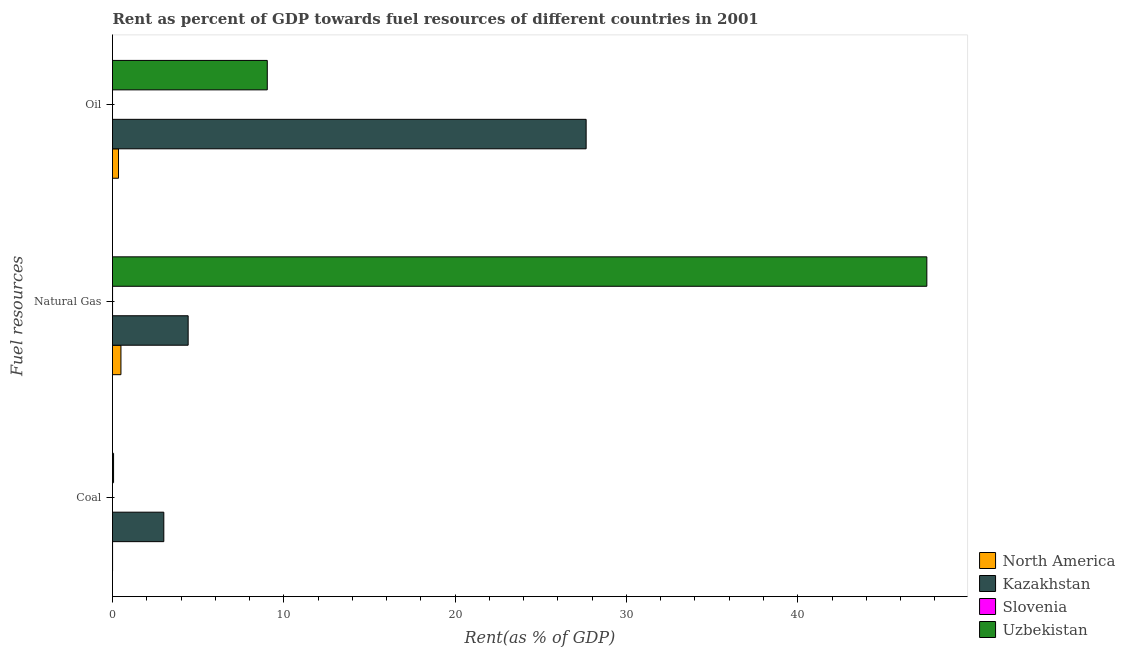Are the number of bars per tick equal to the number of legend labels?
Your answer should be compact. Yes. What is the label of the 3rd group of bars from the top?
Make the answer very short. Coal. What is the rent towards coal in Uzbekistan?
Your response must be concise. 0.06. Across all countries, what is the maximum rent towards oil?
Your response must be concise. 27.65. Across all countries, what is the minimum rent towards natural gas?
Provide a succinct answer. 0. In which country was the rent towards oil maximum?
Your response must be concise. Kazakhstan. In which country was the rent towards oil minimum?
Provide a succinct answer. Slovenia. What is the total rent towards coal in the graph?
Your answer should be compact. 3.06. What is the difference between the rent towards oil in Uzbekistan and that in Kazakhstan?
Offer a very short reply. -18.61. What is the difference between the rent towards coal in North America and the rent towards oil in Slovenia?
Your response must be concise. 0. What is the average rent towards natural gas per country?
Provide a succinct answer. 13.11. What is the difference between the rent towards natural gas and rent towards oil in Slovenia?
Provide a succinct answer. 0. In how many countries, is the rent towards natural gas greater than 44 %?
Keep it short and to the point. 1. What is the ratio of the rent towards coal in Uzbekistan to that in Slovenia?
Your answer should be compact. 720.28. What is the difference between the highest and the second highest rent towards oil?
Give a very brief answer. 18.61. What is the difference between the highest and the lowest rent towards coal?
Make the answer very short. 3. Is the sum of the rent towards coal in Slovenia and North America greater than the maximum rent towards natural gas across all countries?
Ensure brevity in your answer.  No. What does the 1st bar from the top in Natural Gas represents?
Give a very brief answer. Uzbekistan. What does the 4th bar from the bottom in Oil represents?
Ensure brevity in your answer.  Uzbekistan. How many bars are there?
Keep it short and to the point. 12. Are all the bars in the graph horizontal?
Offer a very short reply. Yes. How many countries are there in the graph?
Offer a terse response. 4. What is the difference between two consecutive major ticks on the X-axis?
Your answer should be compact. 10. Are the values on the major ticks of X-axis written in scientific E-notation?
Keep it short and to the point. No. Does the graph contain grids?
Provide a succinct answer. No. Where does the legend appear in the graph?
Your response must be concise. Bottom right. How many legend labels are there?
Ensure brevity in your answer.  4. How are the legend labels stacked?
Offer a terse response. Vertical. What is the title of the graph?
Provide a short and direct response. Rent as percent of GDP towards fuel resources of different countries in 2001. Does "Euro area" appear as one of the legend labels in the graph?
Provide a short and direct response. No. What is the label or title of the X-axis?
Keep it short and to the point. Rent(as % of GDP). What is the label or title of the Y-axis?
Your answer should be very brief. Fuel resources. What is the Rent(as % of GDP) in North America in Coal?
Offer a terse response. 0. What is the Rent(as % of GDP) of Kazakhstan in Coal?
Keep it short and to the point. 3. What is the Rent(as % of GDP) in Slovenia in Coal?
Offer a very short reply. 8.55127305686454e-5. What is the Rent(as % of GDP) of Uzbekistan in Coal?
Give a very brief answer. 0.06. What is the Rent(as % of GDP) in North America in Natural Gas?
Give a very brief answer. 0.49. What is the Rent(as % of GDP) of Kazakhstan in Natural Gas?
Give a very brief answer. 4.42. What is the Rent(as % of GDP) of Slovenia in Natural Gas?
Give a very brief answer. 0. What is the Rent(as % of GDP) in Uzbekistan in Natural Gas?
Ensure brevity in your answer.  47.53. What is the Rent(as % of GDP) in North America in Oil?
Provide a short and direct response. 0.35. What is the Rent(as % of GDP) in Kazakhstan in Oil?
Keep it short and to the point. 27.65. What is the Rent(as % of GDP) in Slovenia in Oil?
Provide a short and direct response. 0. What is the Rent(as % of GDP) in Uzbekistan in Oil?
Provide a short and direct response. 9.03. Across all Fuel resources, what is the maximum Rent(as % of GDP) in North America?
Keep it short and to the point. 0.49. Across all Fuel resources, what is the maximum Rent(as % of GDP) of Kazakhstan?
Offer a terse response. 27.65. Across all Fuel resources, what is the maximum Rent(as % of GDP) in Slovenia?
Give a very brief answer. 0. Across all Fuel resources, what is the maximum Rent(as % of GDP) of Uzbekistan?
Your response must be concise. 47.53. Across all Fuel resources, what is the minimum Rent(as % of GDP) of North America?
Provide a short and direct response. 0. Across all Fuel resources, what is the minimum Rent(as % of GDP) in Kazakhstan?
Provide a succinct answer. 3. Across all Fuel resources, what is the minimum Rent(as % of GDP) in Slovenia?
Your answer should be compact. 8.55127305686454e-5. Across all Fuel resources, what is the minimum Rent(as % of GDP) in Uzbekistan?
Offer a terse response. 0.06. What is the total Rent(as % of GDP) in North America in the graph?
Offer a terse response. 0.85. What is the total Rent(as % of GDP) of Kazakhstan in the graph?
Ensure brevity in your answer.  35.06. What is the total Rent(as % of GDP) of Slovenia in the graph?
Provide a succinct answer. 0. What is the total Rent(as % of GDP) in Uzbekistan in the graph?
Provide a succinct answer. 56.63. What is the difference between the Rent(as % of GDP) in North America in Coal and that in Natural Gas?
Ensure brevity in your answer.  -0.49. What is the difference between the Rent(as % of GDP) of Kazakhstan in Coal and that in Natural Gas?
Offer a very short reply. -1.42. What is the difference between the Rent(as % of GDP) in Slovenia in Coal and that in Natural Gas?
Make the answer very short. -0. What is the difference between the Rent(as % of GDP) of Uzbekistan in Coal and that in Natural Gas?
Keep it short and to the point. -47.47. What is the difference between the Rent(as % of GDP) of North America in Coal and that in Oil?
Keep it short and to the point. -0.35. What is the difference between the Rent(as % of GDP) in Kazakhstan in Coal and that in Oil?
Provide a succinct answer. -24.65. What is the difference between the Rent(as % of GDP) in Slovenia in Coal and that in Oil?
Your answer should be very brief. -0. What is the difference between the Rent(as % of GDP) in Uzbekistan in Coal and that in Oil?
Offer a terse response. -8.97. What is the difference between the Rent(as % of GDP) of North America in Natural Gas and that in Oil?
Make the answer very short. 0.14. What is the difference between the Rent(as % of GDP) of Kazakhstan in Natural Gas and that in Oil?
Your response must be concise. -23.23. What is the difference between the Rent(as % of GDP) in Slovenia in Natural Gas and that in Oil?
Your response must be concise. 0. What is the difference between the Rent(as % of GDP) in Uzbekistan in Natural Gas and that in Oil?
Give a very brief answer. 38.5. What is the difference between the Rent(as % of GDP) of North America in Coal and the Rent(as % of GDP) of Kazakhstan in Natural Gas?
Give a very brief answer. -4.41. What is the difference between the Rent(as % of GDP) of North America in Coal and the Rent(as % of GDP) of Uzbekistan in Natural Gas?
Offer a terse response. -47.53. What is the difference between the Rent(as % of GDP) of Kazakhstan in Coal and the Rent(as % of GDP) of Slovenia in Natural Gas?
Your answer should be very brief. 2.99. What is the difference between the Rent(as % of GDP) in Kazakhstan in Coal and the Rent(as % of GDP) in Uzbekistan in Natural Gas?
Offer a very short reply. -44.54. What is the difference between the Rent(as % of GDP) of Slovenia in Coal and the Rent(as % of GDP) of Uzbekistan in Natural Gas?
Keep it short and to the point. -47.53. What is the difference between the Rent(as % of GDP) of North America in Coal and the Rent(as % of GDP) of Kazakhstan in Oil?
Provide a succinct answer. -27.64. What is the difference between the Rent(as % of GDP) of North America in Coal and the Rent(as % of GDP) of Slovenia in Oil?
Offer a very short reply. 0. What is the difference between the Rent(as % of GDP) in North America in Coal and the Rent(as % of GDP) in Uzbekistan in Oil?
Keep it short and to the point. -9.03. What is the difference between the Rent(as % of GDP) in Kazakhstan in Coal and the Rent(as % of GDP) in Slovenia in Oil?
Offer a terse response. 2.99. What is the difference between the Rent(as % of GDP) of Kazakhstan in Coal and the Rent(as % of GDP) of Uzbekistan in Oil?
Provide a succinct answer. -6.04. What is the difference between the Rent(as % of GDP) of Slovenia in Coal and the Rent(as % of GDP) of Uzbekistan in Oil?
Give a very brief answer. -9.03. What is the difference between the Rent(as % of GDP) of North America in Natural Gas and the Rent(as % of GDP) of Kazakhstan in Oil?
Your answer should be very brief. -27.16. What is the difference between the Rent(as % of GDP) in North America in Natural Gas and the Rent(as % of GDP) in Slovenia in Oil?
Offer a terse response. 0.49. What is the difference between the Rent(as % of GDP) of North America in Natural Gas and the Rent(as % of GDP) of Uzbekistan in Oil?
Offer a terse response. -8.54. What is the difference between the Rent(as % of GDP) in Kazakhstan in Natural Gas and the Rent(as % of GDP) in Slovenia in Oil?
Your answer should be very brief. 4.42. What is the difference between the Rent(as % of GDP) in Kazakhstan in Natural Gas and the Rent(as % of GDP) in Uzbekistan in Oil?
Offer a very short reply. -4.62. What is the difference between the Rent(as % of GDP) of Slovenia in Natural Gas and the Rent(as % of GDP) of Uzbekistan in Oil?
Provide a short and direct response. -9.03. What is the average Rent(as % of GDP) in North America per Fuel resources?
Your response must be concise. 0.28. What is the average Rent(as % of GDP) in Kazakhstan per Fuel resources?
Make the answer very short. 11.69. What is the average Rent(as % of GDP) of Slovenia per Fuel resources?
Your answer should be very brief. 0. What is the average Rent(as % of GDP) in Uzbekistan per Fuel resources?
Keep it short and to the point. 18.88. What is the difference between the Rent(as % of GDP) of North America and Rent(as % of GDP) of Kazakhstan in Coal?
Ensure brevity in your answer.  -2.99. What is the difference between the Rent(as % of GDP) in North America and Rent(as % of GDP) in Slovenia in Coal?
Ensure brevity in your answer.  0. What is the difference between the Rent(as % of GDP) in North America and Rent(as % of GDP) in Uzbekistan in Coal?
Your answer should be very brief. -0.06. What is the difference between the Rent(as % of GDP) of Kazakhstan and Rent(as % of GDP) of Slovenia in Coal?
Provide a short and direct response. 3. What is the difference between the Rent(as % of GDP) in Kazakhstan and Rent(as % of GDP) in Uzbekistan in Coal?
Give a very brief answer. 2.93. What is the difference between the Rent(as % of GDP) in Slovenia and Rent(as % of GDP) in Uzbekistan in Coal?
Make the answer very short. -0.06. What is the difference between the Rent(as % of GDP) in North America and Rent(as % of GDP) in Kazakhstan in Natural Gas?
Your answer should be very brief. -3.92. What is the difference between the Rent(as % of GDP) of North America and Rent(as % of GDP) of Slovenia in Natural Gas?
Your response must be concise. 0.49. What is the difference between the Rent(as % of GDP) of North America and Rent(as % of GDP) of Uzbekistan in Natural Gas?
Provide a short and direct response. -47.04. What is the difference between the Rent(as % of GDP) in Kazakhstan and Rent(as % of GDP) in Slovenia in Natural Gas?
Your answer should be very brief. 4.41. What is the difference between the Rent(as % of GDP) in Kazakhstan and Rent(as % of GDP) in Uzbekistan in Natural Gas?
Keep it short and to the point. -43.12. What is the difference between the Rent(as % of GDP) in Slovenia and Rent(as % of GDP) in Uzbekistan in Natural Gas?
Make the answer very short. -47.53. What is the difference between the Rent(as % of GDP) of North America and Rent(as % of GDP) of Kazakhstan in Oil?
Your response must be concise. -27.3. What is the difference between the Rent(as % of GDP) of North America and Rent(as % of GDP) of Slovenia in Oil?
Give a very brief answer. 0.35. What is the difference between the Rent(as % of GDP) in North America and Rent(as % of GDP) in Uzbekistan in Oil?
Provide a succinct answer. -8.68. What is the difference between the Rent(as % of GDP) of Kazakhstan and Rent(as % of GDP) of Slovenia in Oil?
Make the answer very short. 27.65. What is the difference between the Rent(as % of GDP) in Kazakhstan and Rent(as % of GDP) in Uzbekistan in Oil?
Give a very brief answer. 18.61. What is the difference between the Rent(as % of GDP) in Slovenia and Rent(as % of GDP) in Uzbekistan in Oil?
Keep it short and to the point. -9.03. What is the ratio of the Rent(as % of GDP) in North America in Coal to that in Natural Gas?
Offer a very short reply. 0.01. What is the ratio of the Rent(as % of GDP) in Kazakhstan in Coal to that in Natural Gas?
Keep it short and to the point. 0.68. What is the ratio of the Rent(as % of GDP) of Slovenia in Coal to that in Natural Gas?
Ensure brevity in your answer.  0.03. What is the ratio of the Rent(as % of GDP) of Uzbekistan in Coal to that in Natural Gas?
Your response must be concise. 0. What is the ratio of the Rent(as % of GDP) in North America in Coal to that in Oil?
Provide a short and direct response. 0.01. What is the ratio of the Rent(as % of GDP) in Kazakhstan in Coal to that in Oil?
Ensure brevity in your answer.  0.11. What is the ratio of the Rent(as % of GDP) of Slovenia in Coal to that in Oil?
Your answer should be compact. 0.19. What is the ratio of the Rent(as % of GDP) of Uzbekistan in Coal to that in Oil?
Your answer should be very brief. 0.01. What is the ratio of the Rent(as % of GDP) of North America in Natural Gas to that in Oil?
Offer a terse response. 1.4. What is the ratio of the Rent(as % of GDP) of Kazakhstan in Natural Gas to that in Oil?
Keep it short and to the point. 0.16. What is the ratio of the Rent(as % of GDP) of Slovenia in Natural Gas to that in Oil?
Your response must be concise. 7.04. What is the ratio of the Rent(as % of GDP) of Uzbekistan in Natural Gas to that in Oil?
Give a very brief answer. 5.26. What is the difference between the highest and the second highest Rent(as % of GDP) of North America?
Your answer should be very brief. 0.14. What is the difference between the highest and the second highest Rent(as % of GDP) of Kazakhstan?
Offer a very short reply. 23.23. What is the difference between the highest and the second highest Rent(as % of GDP) in Slovenia?
Provide a succinct answer. 0. What is the difference between the highest and the second highest Rent(as % of GDP) in Uzbekistan?
Your answer should be very brief. 38.5. What is the difference between the highest and the lowest Rent(as % of GDP) of North America?
Make the answer very short. 0.49. What is the difference between the highest and the lowest Rent(as % of GDP) in Kazakhstan?
Give a very brief answer. 24.65. What is the difference between the highest and the lowest Rent(as % of GDP) of Slovenia?
Offer a terse response. 0. What is the difference between the highest and the lowest Rent(as % of GDP) in Uzbekistan?
Your response must be concise. 47.47. 